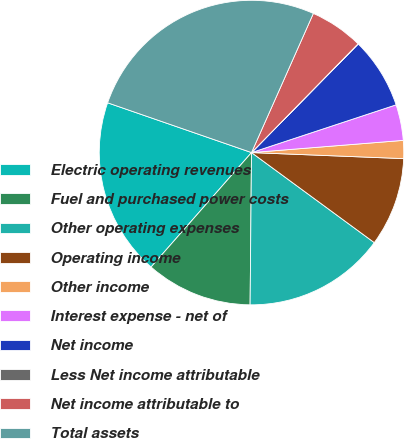Convert chart. <chart><loc_0><loc_0><loc_500><loc_500><pie_chart><fcel>Electric operating revenues<fcel>Fuel and purchased power costs<fcel>Other operating expenses<fcel>Operating income<fcel>Other income<fcel>Interest expense - net of<fcel>Net income<fcel>Less Net income attributable<fcel>Net income attributable to<fcel>Total assets<nl><fcel>18.84%<fcel>11.32%<fcel>15.08%<fcel>9.44%<fcel>1.91%<fcel>3.8%<fcel>7.56%<fcel>0.03%<fcel>5.68%<fcel>26.36%<nl></chart> 